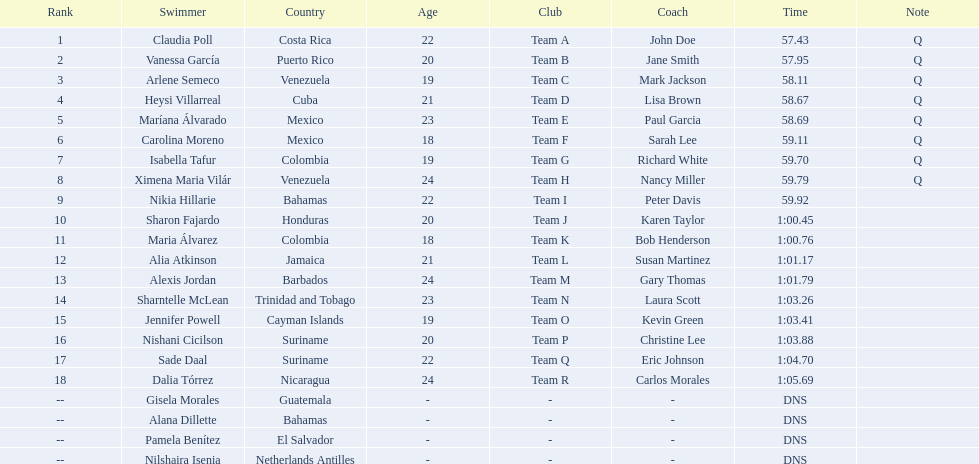Who were all of the swimmers in the women's 100 metre freestyle? Claudia Poll, Vanessa García, Arlene Semeco, Heysi Villarreal, Maríana Álvarado, Carolina Moreno, Isabella Tafur, Ximena Maria Vilár, Nikia Hillarie, Sharon Fajardo, Maria Álvarez, Alia Atkinson, Alexis Jordan, Sharntelle McLean, Jennifer Powell, Nishani Cicilson, Sade Daal, Dalia Tórrez, Gisela Morales, Alana Dillette, Pamela Benítez, Nilshaira Isenia. Where was each swimmer from? Costa Rica, Puerto Rico, Venezuela, Cuba, Mexico, Mexico, Colombia, Venezuela, Bahamas, Honduras, Colombia, Jamaica, Barbados, Trinidad and Tobago, Cayman Islands, Suriname, Suriname, Nicaragua, Guatemala, Bahamas, El Salvador, Netherlands Antilles. What were their ranks? 1, 2, 3, 4, 5, 6, 7, 8, 9, 10, 11, 12, 13, 14, 15, 16, 17, 18, --, --, --, --. Who was in the top eight? Claudia Poll, Vanessa García, Arlene Semeco, Heysi Villarreal, Maríana Álvarado, Carolina Moreno, Isabella Tafur, Ximena Maria Vilár. Of those swimmers, which one was from cuba? Heysi Villarreal. 